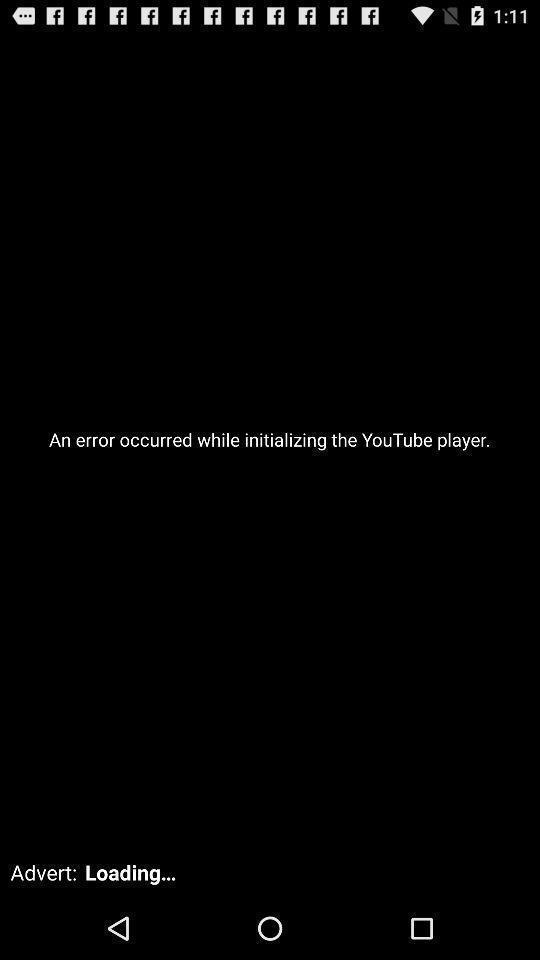Provide a textual representation of this image. Screen shows loading issue while initializing in youtube player. 